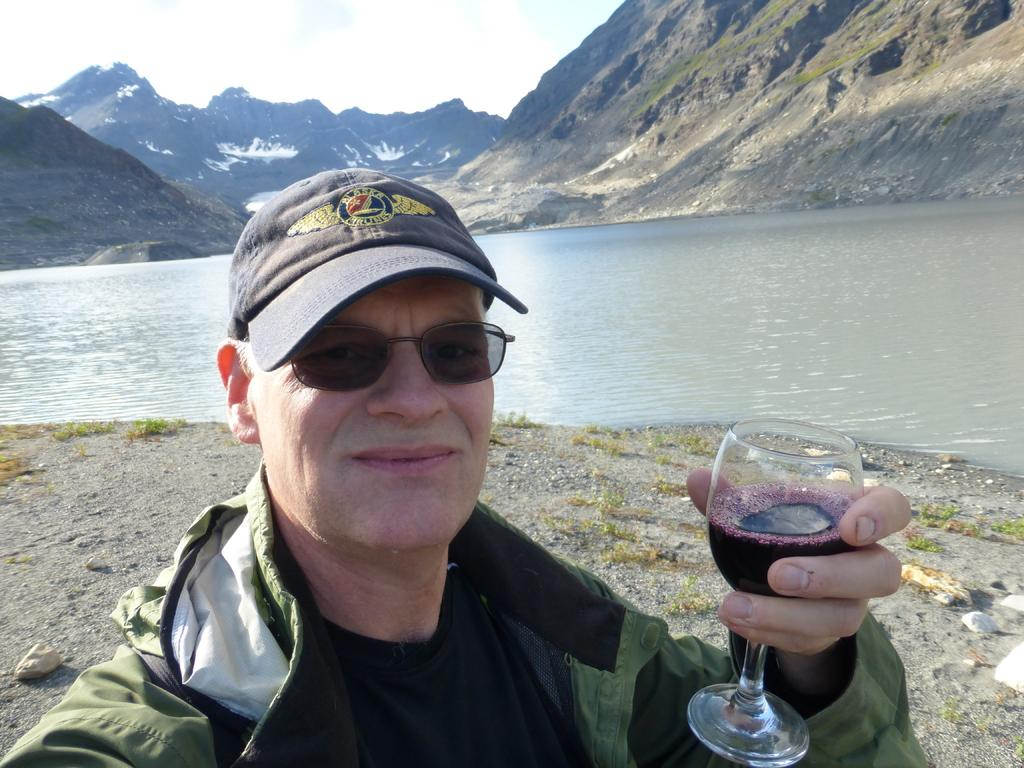What can be seen in the background of the image? There is a sky in the image. What type of landscape is visible in the image? There are hills in the image. What natural element is present in the image? There is water visible in the image. What is the man in the image holding? The man is holding a glass in the image. What type of rhythm does the rat in the image have? There is no rat present in the image. 